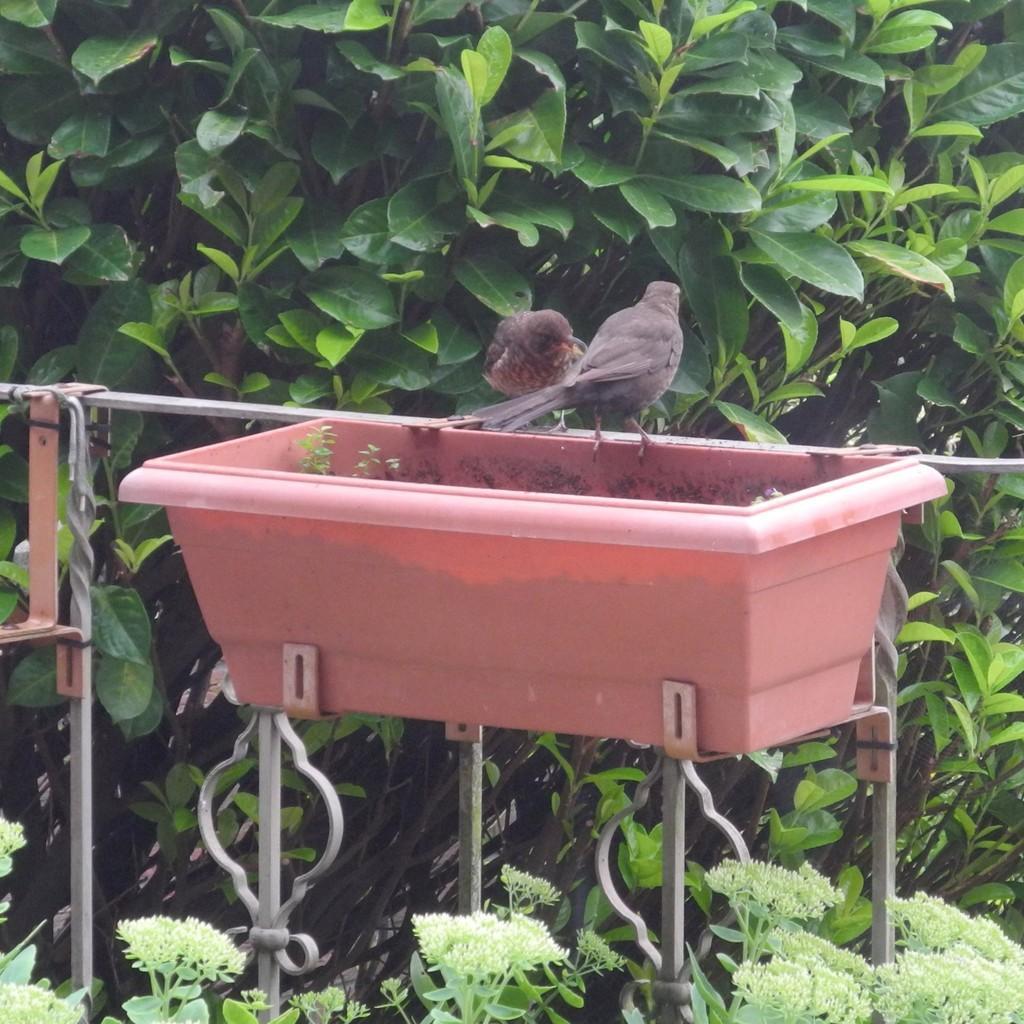Describe this image in one or two sentences. In this image I see the red color basket and I see 2 birds over here which are of grey in color and I see the rods and I see the green leaves on stems. 